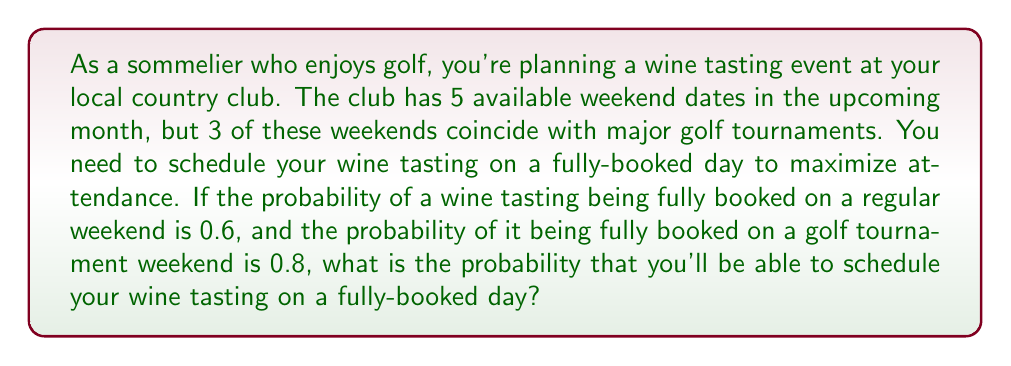Give your solution to this math problem. Let's approach this step-by-step:

1) First, let's define our events:
   A: The event is fully booked
   G: The weekend has a golf tournament

2) We're given the following probabilities:
   $P(A|G) = 0.8$ (probability of being fully booked given it's a golf weekend)
   $P(A|G^c) = 0.6$ (probability of being fully booked given it's not a golf weekend)
   
3) We also know that out of 5 weekends, 3 are golf tournament weekends and 2 are regular weekends:
   $P(G) = \frac{3}{5}$ and $P(G^c) = \frac{2}{5}$

4) We can use the law of total probability to find $P(A)$:

   $$P(A) = P(A|G) \cdot P(G) + P(A|G^c) \cdot P(G^c)$$

5) Substituting our values:

   $$P(A) = 0.8 \cdot \frac{3}{5} + 0.6 \cdot \frac{2}{5}$$

6) Calculating:

   $$P(A) = 0.48 + 0.24 = 0.72$$

Therefore, the probability of scheduling the wine tasting on a fully-booked day is 0.72 or 72%.
Answer: $0.72$ or $72\%$ 